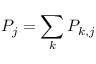<formula> <loc_0><loc_0><loc_500><loc_500>P _ { j } = \sum _ { k } P _ { k , j }</formula> 